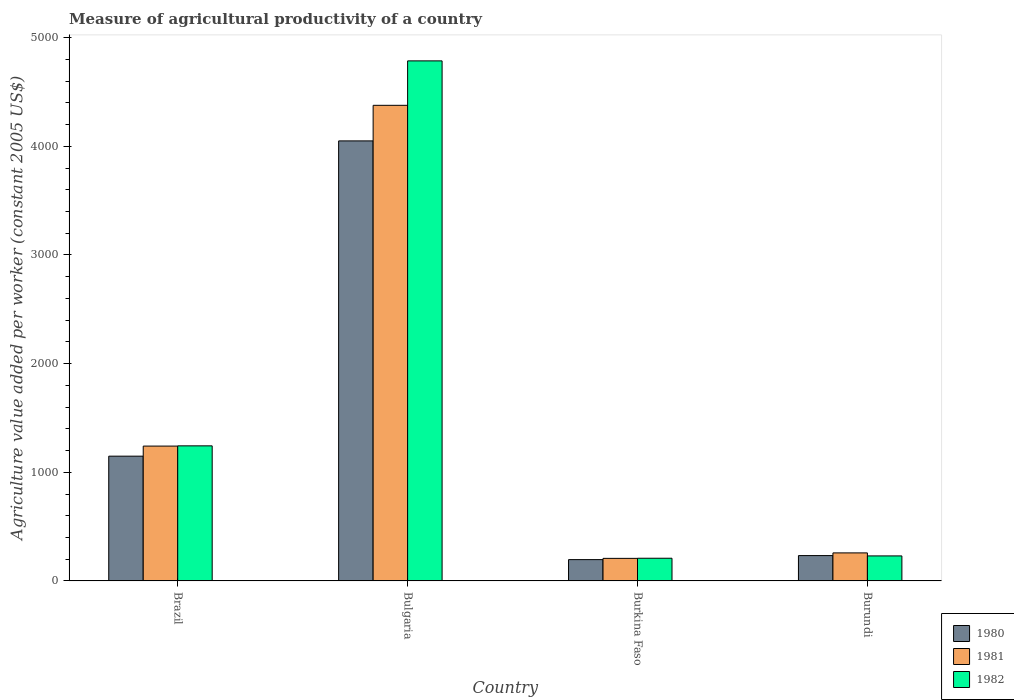How many different coloured bars are there?
Your answer should be compact. 3. How many groups of bars are there?
Offer a terse response. 4. Are the number of bars on each tick of the X-axis equal?
Make the answer very short. Yes. How many bars are there on the 3rd tick from the right?
Keep it short and to the point. 3. What is the label of the 2nd group of bars from the left?
Provide a short and direct response. Bulgaria. What is the measure of agricultural productivity in 1981 in Burundi?
Your response must be concise. 258.11. Across all countries, what is the maximum measure of agricultural productivity in 1981?
Make the answer very short. 4377.54. Across all countries, what is the minimum measure of agricultural productivity in 1982?
Give a very brief answer. 208.91. In which country was the measure of agricultural productivity in 1982 maximum?
Provide a succinct answer. Bulgaria. In which country was the measure of agricultural productivity in 1981 minimum?
Offer a very short reply. Burkina Faso. What is the total measure of agricultural productivity in 1981 in the graph?
Provide a short and direct response. 6084.64. What is the difference between the measure of agricultural productivity in 1982 in Burkina Faso and that in Burundi?
Keep it short and to the point. -21.37. What is the difference between the measure of agricultural productivity in 1982 in Burkina Faso and the measure of agricultural productivity in 1981 in Bulgaria?
Offer a terse response. -4168.63. What is the average measure of agricultural productivity in 1982 per country?
Offer a terse response. 1617.24. What is the difference between the measure of agricultural productivity of/in 1980 and measure of agricultural productivity of/in 1981 in Burkina Faso?
Your answer should be very brief. -11.54. In how many countries, is the measure of agricultural productivity in 1980 greater than 2800 US$?
Ensure brevity in your answer.  1. What is the ratio of the measure of agricultural productivity in 1981 in Brazil to that in Burkina Faso?
Your answer should be very brief. 5.97. What is the difference between the highest and the second highest measure of agricultural productivity in 1980?
Offer a very short reply. 2901.51. What is the difference between the highest and the lowest measure of agricultural productivity in 1981?
Give a very brief answer. 4169.76. In how many countries, is the measure of agricultural productivity in 1980 greater than the average measure of agricultural productivity in 1980 taken over all countries?
Make the answer very short. 1. Is it the case that in every country, the sum of the measure of agricultural productivity in 1981 and measure of agricultural productivity in 1980 is greater than the measure of agricultural productivity in 1982?
Provide a short and direct response. Yes. How many countries are there in the graph?
Provide a short and direct response. 4. Are the values on the major ticks of Y-axis written in scientific E-notation?
Keep it short and to the point. No. Does the graph contain grids?
Your response must be concise. No. What is the title of the graph?
Offer a terse response. Measure of agricultural productivity of a country. What is the label or title of the Y-axis?
Your answer should be very brief. Agriculture value added per worker (constant 2005 US$). What is the Agriculture value added per worker (constant 2005 US$) of 1980 in Brazil?
Your answer should be very brief. 1148.46. What is the Agriculture value added per worker (constant 2005 US$) in 1981 in Brazil?
Provide a short and direct response. 1241.2. What is the Agriculture value added per worker (constant 2005 US$) of 1982 in Brazil?
Offer a very short reply. 1243.26. What is the Agriculture value added per worker (constant 2005 US$) in 1980 in Bulgaria?
Your answer should be very brief. 4049.97. What is the Agriculture value added per worker (constant 2005 US$) in 1981 in Bulgaria?
Offer a very short reply. 4377.54. What is the Agriculture value added per worker (constant 2005 US$) in 1982 in Bulgaria?
Your answer should be very brief. 4786.52. What is the Agriculture value added per worker (constant 2005 US$) of 1980 in Burkina Faso?
Ensure brevity in your answer.  196.25. What is the Agriculture value added per worker (constant 2005 US$) of 1981 in Burkina Faso?
Offer a very short reply. 207.78. What is the Agriculture value added per worker (constant 2005 US$) of 1982 in Burkina Faso?
Your response must be concise. 208.91. What is the Agriculture value added per worker (constant 2005 US$) in 1980 in Burundi?
Ensure brevity in your answer.  233.32. What is the Agriculture value added per worker (constant 2005 US$) in 1981 in Burundi?
Make the answer very short. 258.11. What is the Agriculture value added per worker (constant 2005 US$) in 1982 in Burundi?
Provide a succinct answer. 230.29. Across all countries, what is the maximum Agriculture value added per worker (constant 2005 US$) of 1980?
Offer a terse response. 4049.97. Across all countries, what is the maximum Agriculture value added per worker (constant 2005 US$) in 1981?
Offer a terse response. 4377.54. Across all countries, what is the maximum Agriculture value added per worker (constant 2005 US$) in 1982?
Keep it short and to the point. 4786.52. Across all countries, what is the minimum Agriculture value added per worker (constant 2005 US$) of 1980?
Make the answer very short. 196.25. Across all countries, what is the minimum Agriculture value added per worker (constant 2005 US$) in 1981?
Keep it short and to the point. 207.78. Across all countries, what is the minimum Agriculture value added per worker (constant 2005 US$) of 1982?
Provide a succinct answer. 208.91. What is the total Agriculture value added per worker (constant 2005 US$) in 1980 in the graph?
Make the answer very short. 5627.99. What is the total Agriculture value added per worker (constant 2005 US$) in 1981 in the graph?
Offer a terse response. 6084.64. What is the total Agriculture value added per worker (constant 2005 US$) of 1982 in the graph?
Keep it short and to the point. 6468.98. What is the difference between the Agriculture value added per worker (constant 2005 US$) of 1980 in Brazil and that in Bulgaria?
Your answer should be very brief. -2901.51. What is the difference between the Agriculture value added per worker (constant 2005 US$) in 1981 in Brazil and that in Bulgaria?
Ensure brevity in your answer.  -3136.34. What is the difference between the Agriculture value added per worker (constant 2005 US$) of 1982 in Brazil and that in Bulgaria?
Ensure brevity in your answer.  -3543.26. What is the difference between the Agriculture value added per worker (constant 2005 US$) of 1980 in Brazil and that in Burkina Faso?
Ensure brevity in your answer.  952.21. What is the difference between the Agriculture value added per worker (constant 2005 US$) in 1981 in Brazil and that in Burkina Faso?
Give a very brief answer. 1033.42. What is the difference between the Agriculture value added per worker (constant 2005 US$) of 1982 in Brazil and that in Burkina Faso?
Offer a terse response. 1034.35. What is the difference between the Agriculture value added per worker (constant 2005 US$) in 1980 in Brazil and that in Burundi?
Your response must be concise. 915.13. What is the difference between the Agriculture value added per worker (constant 2005 US$) in 1981 in Brazil and that in Burundi?
Provide a succinct answer. 983.09. What is the difference between the Agriculture value added per worker (constant 2005 US$) in 1982 in Brazil and that in Burundi?
Make the answer very short. 1012.97. What is the difference between the Agriculture value added per worker (constant 2005 US$) of 1980 in Bulgaria and that in Burkina Faso?
Provide a succinct answer. 3853.72. What is the difference between the Agriculture value added per worker (constant 2005 US$) of 1981 in Bulgaria and that in Burkina Faso?
Your answer should be compact. 4169.76. What is the difference between the Agriculture value added per worker (constant 2005 US$) of 1982 in Bulgaria and that in Burkina Faso?
Your answer should be very brief. 4577.61. What is the difference between the Agriculture value added per worker (constant 2005 US$) in 1980 in Bulgaria and that in Burundi?
Give a very brief answer. 3816.65. What is the difference between the Agriculture value added per worker (constant 2005 US$) in 1981 in Bulgaria and that in Burundi?
Ensure brevity in your answer.  4119.43. What is the difference between the Agriculture value added per worker (constant 2005 US$) in 1982 in Bulgaria and that in Burundi?
Offer a terse response. 4556.24. What is the difference between the Agriculture value added per worker (constant 2005 US$) in 1980 in Burkina Faso and that in Burundi?
Provide a succinct answer. -37.08. What is the difference between the Agriculture value added per worker (constant 2005 US$) of 1981 in Burkina Faso and that in Burundi?
Your answer should be very brief. -50.33. What is the difference between the Agriculture value added per worker (constant 2005 US$) of 1982 in Burkina Faso and that in Burundi?
Your response must be concise. -21.37. What is the difference between the Agriculture value added per worker (constant 2005 US$) in 1980 in Brazil and the Agriculture value added per worker (constant 2005 US$) in 1981 in Bulgaria?
Your answer should be compact. -3229.09. What is the difference between the Agriculture value added per worker (constant 2005 US$) of 1980 in Brazil and the Agriculture value added per worker (constant 2005 US$) of 1982 in Bulgaria?
Offer a very short reply. -3638.07. What is the difference between the Agriculture value added per worker (constant 2005 US$) of 1981 in Brazil and the Agriculture value added per worker (constant 2005 US$) of 1982 in Bulgaria?
Make the answer very short. -3545.32. What is the difference between the Agriculture value added per worker (constant 2005 US$) of 1980 in Brazil and the Agriculture value added per worker (constant 2005 US$) of 1981 in Burkina Faso?
Provide a succinct answer. 940.67. What is the difference between the Agriculture value added per worker (constant 2005 US$) in 1980 in Brazil and the Agriculture value added per worker (constant 2005 US$) in 1982 in Burkina Faso?
Keep it short and to the point. 939.54. What is the difference between the Agriculture value added per worker (constant 2005 US$) in 1981 in Brazil and the Agriculture value added per worker (constant 2005 US$) in 1982 in Burkina Faso?
Your answer should be very brief. 1032.29. What is the difference between the Agriculture value added per worker (constant 2005 US$) in 1980 in Brazil and the Agriculture value added per worker (constant 2005 US$) in 1981 in Burundi?
Your answer should be compact. 890.34. What is the difference between the Agriculture value added per worker (constant 2005 US$) in 1980 in Brazil and the Agriculture value added per worker (constant 2005 US$) in 1982 in Burundi?
Your response must be concise. 918.17. What is the difference between the Agriculture value added per worker (constant 2005 US$) in 1981 in Brazil and the Agriculture value added per worker (constant 2005 US$) in 1982 in Burundi?
Your answer should be very brief. 1010.92. What is the difference between the Agriculture value added per worker (constant 2005 US$) in 1980 in Bulgaria and the Agriculture value added per worker (constant 2005 US$) in 1981 in Burkina Faso?
Your response must be concise. 3842.18. What is the difference between the Agriculture value added per worker (constant 2005 US$) in 1980 in Bulgaria and the Agriculture value added per worker (constant 2005 US$) in 1982 in Burkina Faso?
Give a very brief answer. 3841.06. What is the difference between the Agriculture value added per worker (constant 2005 US$) in 1981 in Bulgaria and the Agriculture value added per worker (constant 2005 US$) in 1982 in Burkina Faso?
Provide a short and direct response. 4168.63. What is the difference between the Agriculture value added per worker (constant 2005 US$) of 1980 in Bulgaria and the Agriculture value added per worker (constant 2005 US$) of 1981 in Burundi?
Ensure brevity in your answer.  3791.86. What is the difference between the Agriculture value added per worker (constant 2005 US$) of 1980 in Bulgaria and the Agriculture value added per worker (constant 2005 US$) of 1982 in Burundi?
Offer a very short reply. 3819.68. What is the difference between the Agriculture value added per worker (constant 2005 US$) in 1981 in Bulgaria and the Agriculture value added per worker (constant 2005 US$) in 1982 in Burundi?
Your answer should be very brief. 4147.26. What is the difference between the Agriculture value added per worker (constant 2005 US$) in 1980 in Burkina Faso and the Agriculture value added per worker (constant 2005 US$) in 1981 in Burundi?
Keep it short and to the point. -61.86. What is the difference between the Agriculture value added per worker (constant 2005 US$) in 1980 in Burkina Faso and the Agriculture value added per worker (constant 2005 US$) in 1982 in Burundi?
Your answer should be very brief. -34.04. What is the difference between the Agriculture value added per worker (constant 2005 US$) of 1981 in Burkina Faso and the Agriculture value added per worker (constant 2005 US$) of 1982 in Burundi?
Your response must be concise. -22.5. What is the average Agriculture value added per worker (constant 2005 US$) of 1980 per country?
Give a very brief answer. 1407. What is the average Agriculture value added per worker (constant 2005 US$) in 1981 per country?
Offer a very short reply. 1521.16. What is the average Agriculture value added per worker (constant 2005 US$) in 1982 per country?
Provide a succinct answer. 1617.24. What is the difference between the Agriculture value added per worker (constant 2005 US$) of 1980 and Agriculture value added per worker (constant 2005 US$) of 1981 in Brazil?
Keep it short and to the point. -92.75. What is the difference between the Agriculture value added per worker (constant 2005 US$) of 1980 and Agriculture value added per worker (constant 2005 US$) of 1982 in Brazil?
Your response must be concise. -94.81. What is the difference between the Agriculture value added per worker (constant 2005 US$) of 1981 and Agriculture value added per worker (constant 2005 US$) of 1982 in Brazil?
Offer a terse response. -2.06. What is the difference between the Agriculture value added per worker (constant 2005 US$) of 1980 and Agriculture value added per worker (constant 2005 US$) of 1981 in Bulgaria?
Make the answer very short. -327.57. What is the difference between the Agriculture value added per worker (constant 2005 US$) of 1980 and Agriculture value added per worker (constant 2005 US$) of 1982 in Bulgaria?
Provide a succinct answer. -736.55. What is the difference between the Agriculture value added per worker (constant 2005 US$) of 1981 and Agriculture value added per worker (constant 2005 US$) of 1982 in Bulgaria?
Your answer should be compact. -408.98. What is the difference between the Agriculture value added per worker (constant 2005 US$) of 1980 and Agriculture value added per worker (constant 2005 US$) of 1981 in Burkina Faso?
Keep it short and to the point. -11.54. What is the difference between the Agriculture value added per worker (constant 2005 US$) of 1980 and Agriculture value added per worker (constant 2005 US$) of 1982 in Burkina Faso?
Provide a short and direct response. -12.66. What is the difference between the Agriculture value added per worker (constant 2005 US$) of 1981 and Agriculture value added per worker (constant 2005 US$) of 1982 in Burkina Faso?
Your response must be concise. -1.13. What is the difference between the Agriculture value added per worker (constant 2005 US$) of 1980 and Agriculture value added per worker (constant 2005 US$) of 1981 in Burundi?
Your answer should be compact. -24.79. What is the difference between the Agriculture value added per worker (constant 2005 US$) in 1980 and Agriculture value added per worker (constant 2005 US$) in 1982 in Burundi?
Offer a very short reply. 3.04. What is the difference between the Agriculture value added per worker (constant 2005 US$) of 1981 and Agriculture value added per worker (constant 2005 US$) of 1982 in Burundi?
Provide a short and direct response. 27.82. What is the ratio of the Agriculture value added per worker (constant 2005 US$) of 1980 in Brazil to that in Bulgaria?
Offer a terse response. 0.28. What is the ratio of the Agriculture value added per worker (constant 2005 US$) in 1981 in Brazil to that in Bulgaria?
Give a very brief answer. 0.28. What is the ratio of the Agriculture value added per worker (constant 2005 US$) in 1982 in Brazil to that in Bulgaria?
Keep it short and to the point. 0.26. What is the ratio of the Agriculture value added per worker (constant 2005 US$) in 1980 in Brazil to that in Burkina Faso?
Your answer should be compact. 5.85. What is the ratio of the Agriculture value added per worker (constant 2005 US$) in 1981 in Brazil to that in Burkina Faso?
Give a very brief answer. 5.97. What is the ratio of the Agriculture value added per worker (constant 2005 US$) of 1982 in Brazil to that in Burkina Faso?
Offer a terse response. 5.95. What is the ratio of the Agriculture value added per worker (constant 2005 US$) in 1980 in Brazil to that in Burundi?
Offer a very short reply. 4.92. What is the ratio of the Agriculture value added per worker (constant 2005 US$) in 1981 in Brazil to that in Burundi?
Provide a succinct answer. 4.81. What is the ratio of the Agriculture value added per worker (constant 2005 US$) in 1982 in Brazil to that in Burundi?
Provide a short and direct response. 5.4. What is the ratio of the Agriculture value added per worker (constant 2005 US$) in 1980 in Bulgaria to that in Burkina Faso?
Keep it short and to the point. 20.64. What is the ratio of the Agriculture value added per worker (constant 2005 US$) of 1981 in Bulgaria to that in Burkina Faso?
Your response must be concise. 21.07. What is the ratio of the Agriculture value added per worker (constant 2005 US$) in 1982 in Bulgaria to that in Burkina Faso?
Make the answer very short. 22.91. What is the ratio of the Agriculture value added per worker (constant 2005 US$) in 1980 in Bulgaria to that in Burundi?
Give a very brief answer. 17.36. What is the ratio of the Agriculture value added per worker (constant 2005 US$) in 1981 in Bulgaria to that in Burundi?
Make the answer very short. 16.96. What is the ratio of the Agriculture value added per worker (constant 2005 US$) of 1982 in Bulgaria to that in Burundi?
Offer a very short reply. 20.79. What is the ratio of the Agriculture value added per worker (constant 2005 US$) of 1980 in Burkina Faso to that in Burundi?
Provide a short and direct response. 0.84. What is the ratio of the Agriculture value added per worker (constant 2005 US$) in 1981 in Burkina Faso to that in Burundi?
Give a very brief answer. 0.81. What is the ratio of the Agriculture value added per worker (constant 2005 US$) of 1982 in Burkina Faso to that in Burundi?
Your response must be concise. 0.91. What is the difference between the highest and the second highest Agriculture value added per worker (constant 2005 US$) in 1980?
Offer a terse response. 2901.51. What is the difference between the highest and the second highest Agriculture value added per worker (constant 2005 US$) in 1981?
Provide a short and direct response. 3136.34. What is the difference between the highest and the second highest Agriculture value added per worker (constant 2005 US$) of 1982?
Your answer should be very brief. 3543.26. What is the difference between the highest and the lowest Agriculture value added per worker (constant 2005 US$) of 1980?
Keep it short and to the point. 3853.72. What is the difference between the highest and the lowest Agriculture value added per worker (constant 2005 US$) of 1981?
Provide a short and direct response. 4169.76. What is the difference between the highest and the lowest Agriculture value added per worker (constant 2005 US$) in 1982?
Your answer should be compact. 4577.61. 